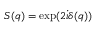<formula> <loc_0><loc_0><loc_500><loc_500>S ( q ) = \exp ( 2 \dot { \iota } \delta ( q ) )</formula> 